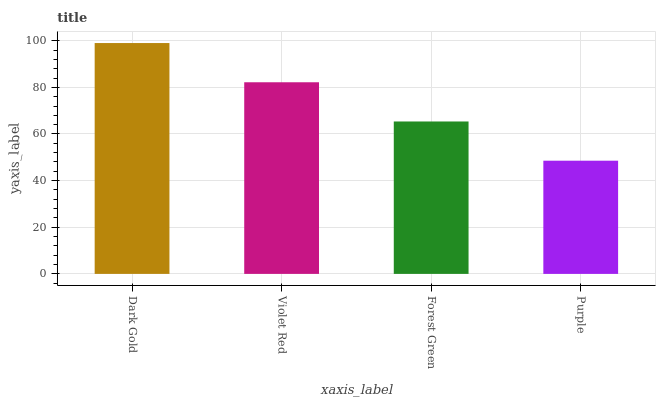Is Purple the minimum?
Answer yes or no. Yes. Is Dark Gold the maximum?
Answer yes or no. Yes. Is Violet Red the minimum?
Answer yes or no. No. Is Violet Red the maximum?
Answer yes or no. No. Is Dark Gold greater than Violet Red?
Answer yes or no. Yes. Is Violet Red less than Dark Gold?
Answer yes or no. Yes. Is Violet Red greater than Dark Gold?
Answer yes or no. No. Is Dark Gold less than Violet Red?
Answer yes or no. No. Is Violet Red the high median?
Answer yes or no. Yes. Is Forest Green the low median?
Answer yes or no. Yes. Is Dark Gold the high median?
Answer yes or no. No. Is Dark Gold the low median?
Answer yes or no. No. 